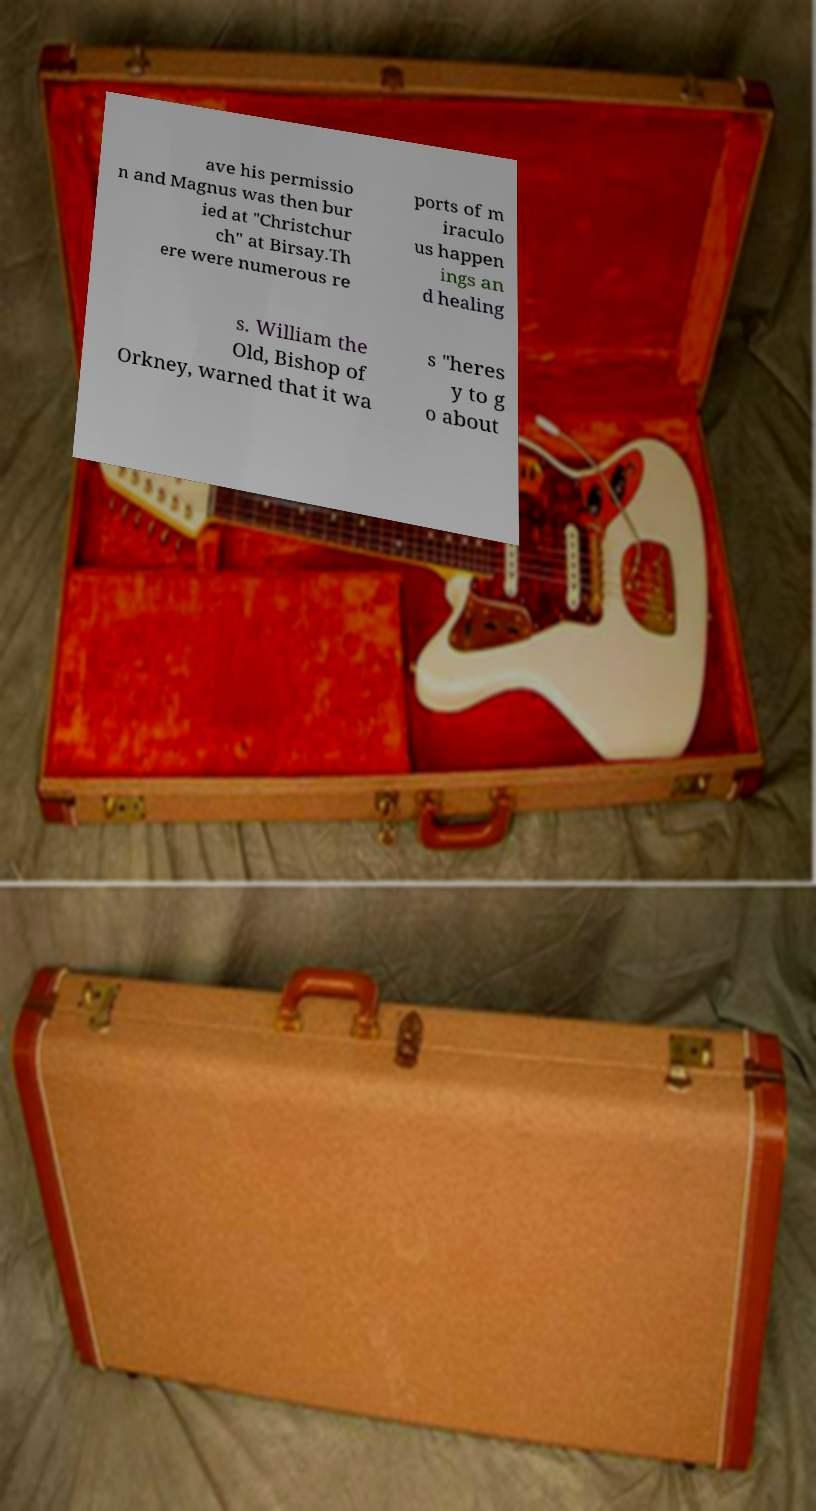For documentation purposes, I need the text within this image transcribed. Could you provide that? ave his permissio n and Magnus was then bur ied at "Christchur ch" at Birsay.Th ere were numerous re ports of m iraculo us happen ings an d healing s. William the Old, Bishop of Orkney, warned that it wa s "heres y to g o about 